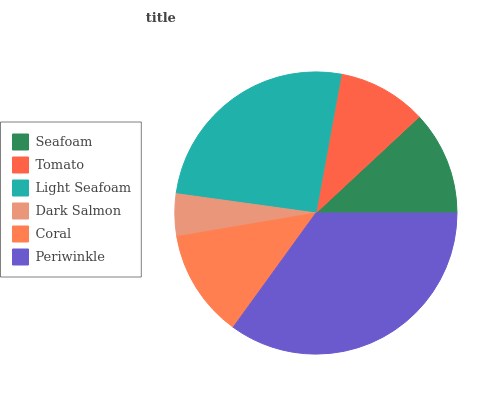Is Dark Salmon the minimum?
Answer yes or no. Yes. Is Periwinkle the maximum?
Answer yes or no. Yes. Is Tomato the minimum?
Answer yes or no. No. Is Tomato the maximum?
Answer yes or no. No. Is Seafoam greater than Tomato?
Answer yes or no. Yes. Is Tomato less than Seafoam?
Answer yes or no. Yes. Is Tomato greater than Seafoam?
Answer yes or no. No. Is Seafoam less than Tomato?
Answer yes or no. No. Is Coral the high median?
Answer yes or no. Yes. Is Seafoam the low median?
Answer yes or no. Yes. Is Light Seafoam the high median?
Answer yes or no. No. Is Coral the low median?
Answer yes or no. No. 